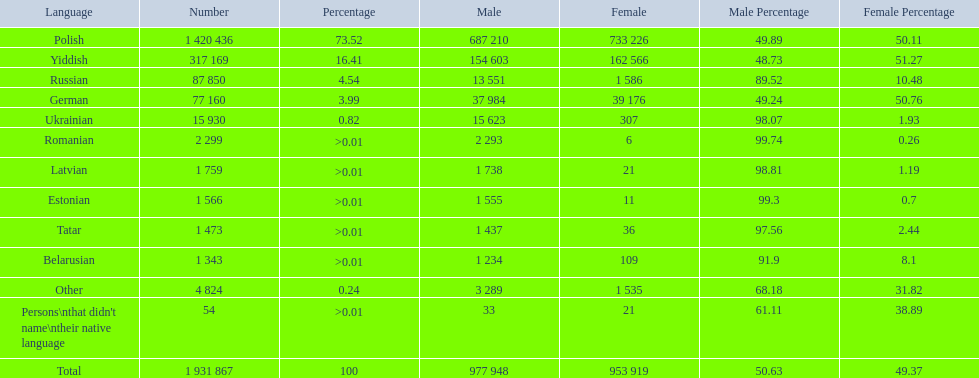What are all the spoken languages? Polish, Yiddish, Russian, German, Ukrainian, Romanian, Latvian, Estonian, Tatar, Belarusian. Which one of these has the most people speaking it? Polish. 